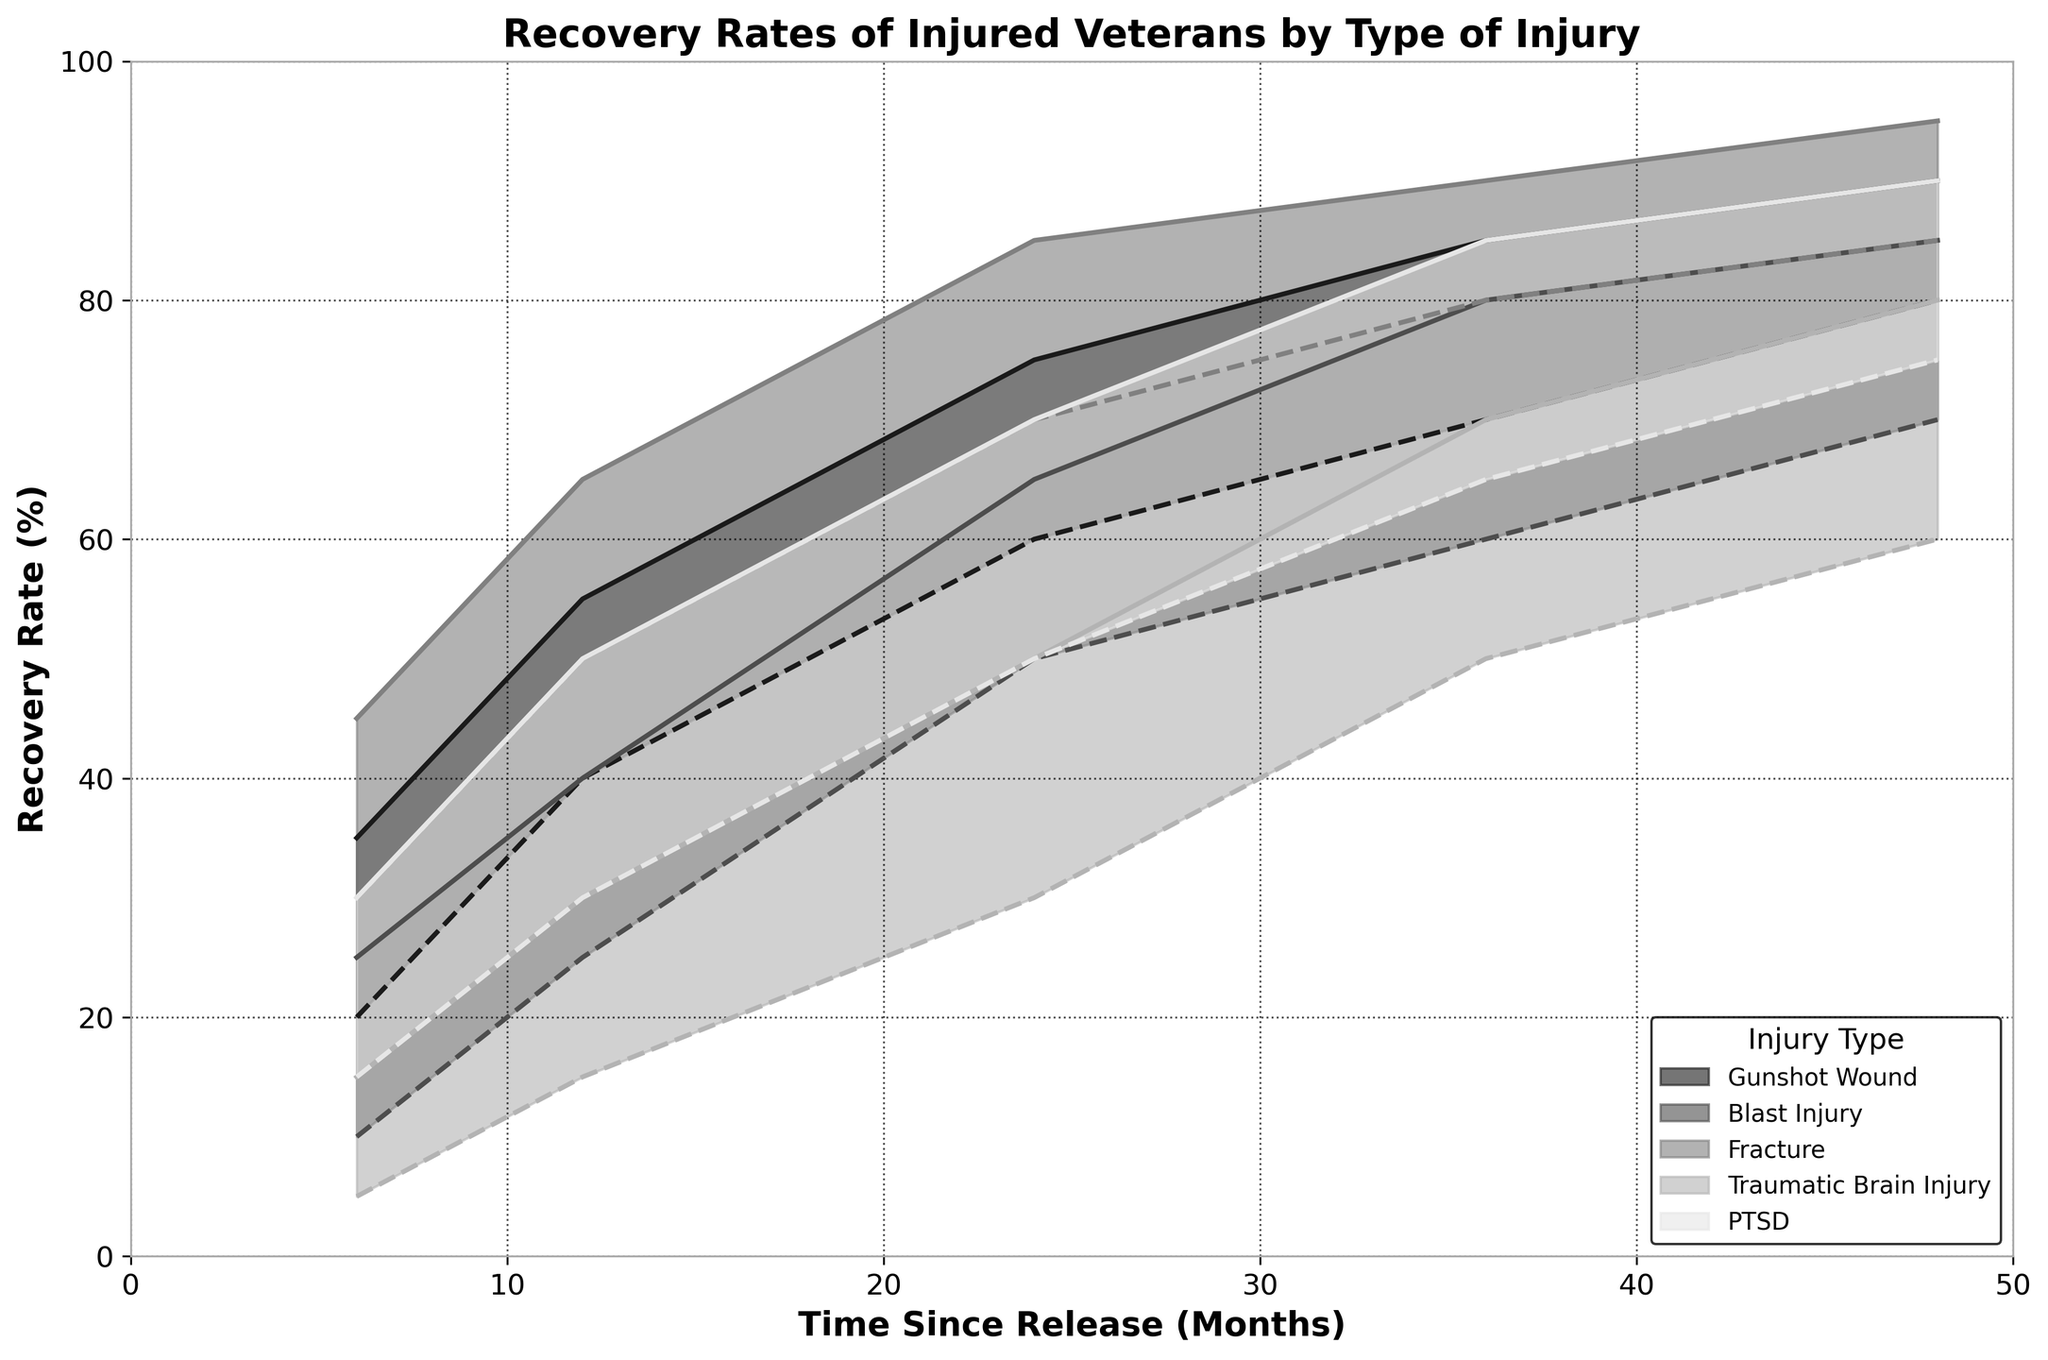What is the title of the graph? The title is displayed at the top of the graph, which reads "Recovery Rates of Injured Veterans by Type of Injury".
Answer: Recovery Rates of Injured Veterans by Type of Injury How many types of injuries are displayed in the graph? By looking at the legend at the bottom right of the graph, we can see that there are five types of injuries listed: Gunshot Wound, Blast Injury, Fracture, Traumatic Brain Injury, and PTSD.
Answer: 5 Which injury type shows the highest maximum recovery rate after 48 months? We need to look at the highest recovery rate at 48 months for all injury types. Fracture reaches a maximum recovery rate of 95%, which is higher than other injury types.
Answer: Fracture What is the minimum recovery rate for PTSD after 12 months? Refer to the plot for the recovery rates of PTSD at the 12-month mark. The minimum recovery rate at this point is 30%.
Answer: 30% Which injury type has the lowest starting (6 months) maximum recovery rate? Check the maximum recovery rates at 6 months for all injury types and compare them. Traumatic Brain Injury has the lowest at 15%.
Answer: Traumatic Brain Injury By how much does the minimum recovery rate for Gunshot Wound increase from 6 months to 24 months? Subtract the minimum recovery rate at 6 months (20%) from the minimum recovery rate at 24 months (60%). 60% - 20% = 40%
Answer: 40% What is the range of recovery rates for Blast Injury at 36 months? The plot shows the minimum and maximum recovery rates at 36 months for Blast Injury, which are 60% and 80%, respectively. The range is 80% - 60% = 20%.
Answer: 20% Compare the recovery rate ranges (both min and max) between Gunshot Wound and PTSD at 24 months. Which shows a larger range? For Gunshot Wound, the range at 24 months is 60% to 75% (15%). For PTSD, it is 50% to 70% (20%). PTSD shows a larger range.
Answer: PTSD What is the general trend of recovery rates over time for the Fracture injury type? Examine the plot line for Fracture. The recovery rate consistently increases over time, both for minimum and maximum rates, showing a positive trend.
Answer: Increasing How does the range of recovery rates for Traumatic Brain Injury at 48 months compare to the same period for Fracture? At 48 months, the range for Traumatic Brain Injury is 60% to 80% (20%) and for Fracture is 85% to 95% (10%). Traumatic Brain Injury has a larger range.
Answer: Traumatic Brain Injury 